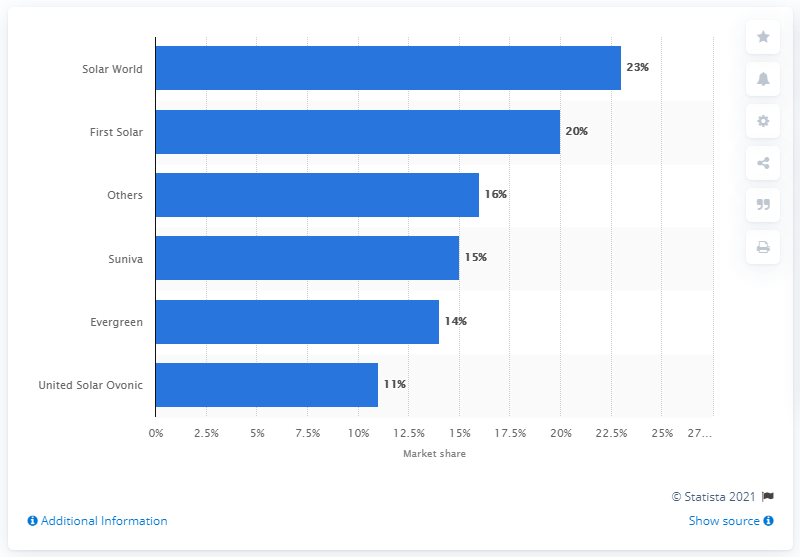Mention a couple of crucial points in this snapshot. What was First Solar's market share in 2010? According to the report, First Solar's market share in 2010 was approximately 20%. First Solar was the manufacturer with a market share of approximately 20 percent in 2010. 